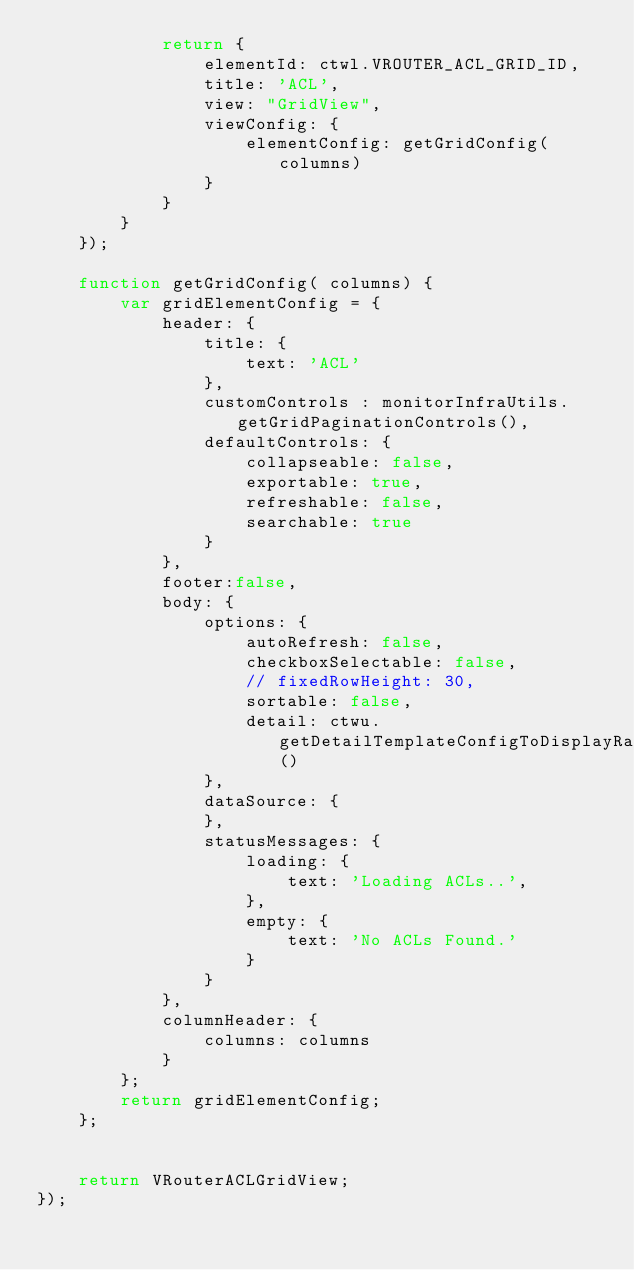<code> <loc_0><loc_0><loc_500><loc_500><_JavaScript_>            return {
                elementId: ctwl.VROUTER_ACL_GRID_ID,
                title: 'ACL',
                view: "GridView",
                viewConfig: {
                    elementConfig: getGridConfig( columns)
                }
            }
        }
    });

    function getGridConfig( columns) {
        var gridElementConfig = {
            header: {
                title: {
                    text: 'ACL'
                },
                customControls : monitorInfraUtils.getGridPaginationControls(),
                defaultControls: {
                    collapseable: false,
                    exportable: true,
                    refreshable: false,
                    searchable: true
                }
            },
            footer:false,
            body: {
                options: {
                    autoRefresh: false,
                    checkboxSelectable: false,
                    // fixedRowHeight: 30,
                    sortable: false,
                    detail: ctwu.getDetailTemplateConfigToDisplayRawJSON()
                },
                dataSource: {
                },
                statusMessages: {
                    loading: {
                        text: 'Loading ACLs..',
                    },
                    empty: {
                        text: 'No ACLs Found.'
                    }
                }
            },
            columnHeader: {
                columns: columns
            }
        };
        return gridElementConfig;
    };


    return VRouterACLGridView;
});
</code> 